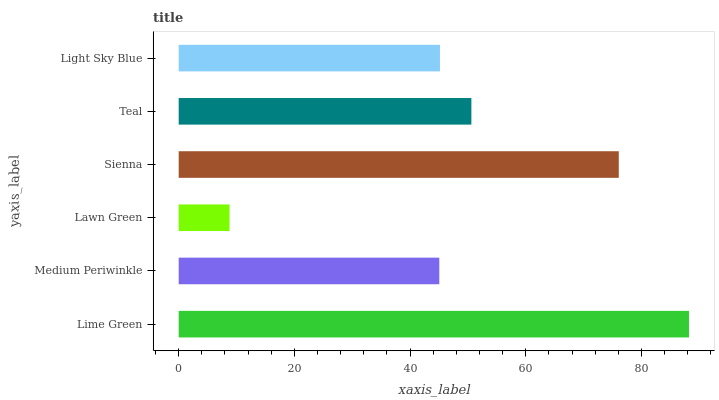Is Lawn Green the minimum?
Answer yes or no. Yes. Is Lime Green the maximum?
Answer yes or no. Yes. Is Medium Periwinkle the minimum?
Answer yes or no. No. Is Medium Periwinkle the maximum?
Answer yes or no. No. Is Lime Green greater than Medium Periwinkle?
Answer yes or no. Yes. Is Medium Periwinkle less than Lime Green?
Answer yes or no. Yes. Is Medium Periwinkle greater than Lime Green?
Answer yes or no. No. Is Lime Green less than Medium Periwinkle?
Answer yes or no. No. Is Teal the high median?
Answer yes or no. Yes. Is Light Sky Blue the low median?
Answer yes or no. Yes. Is Sienna the high median?
Answer yes or no. No. Is Sienna the low median?
Answer yes or no. No. 